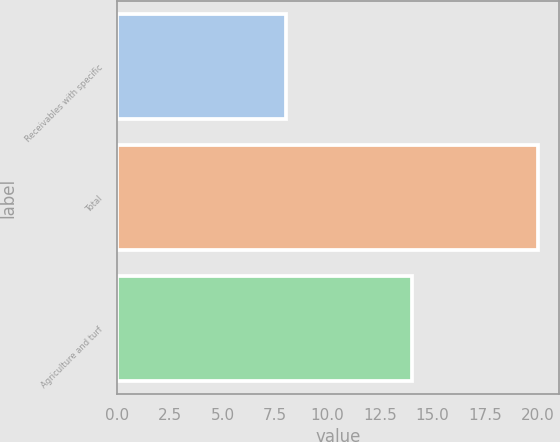<chart> <loc_0><loc_0><loc_500><loc_500><bar_chart><fcel>Receivables with specific<fcel>Total<fcel>Agriculture and turf<nl><fcel>8<fcel>20<fcel>14<nl></chart> 